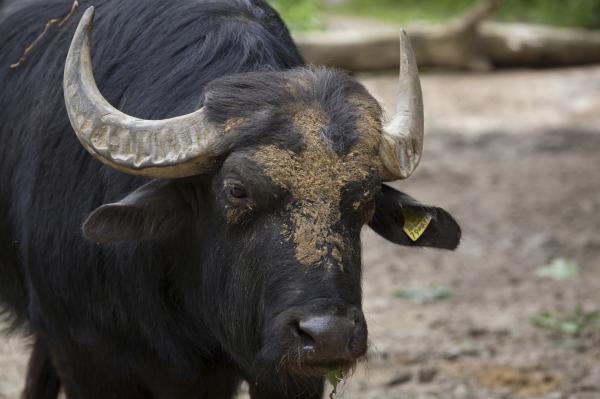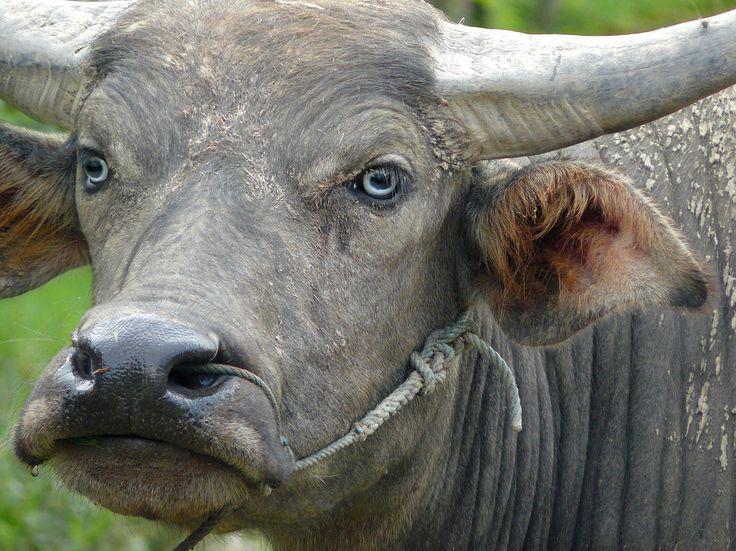The first image is the image on the left, the second image is the image on the right. Analyze the images presented: Is the assertion "In each image the water buffalo's horns are completely visible." valid? Answer yes or no. No. 